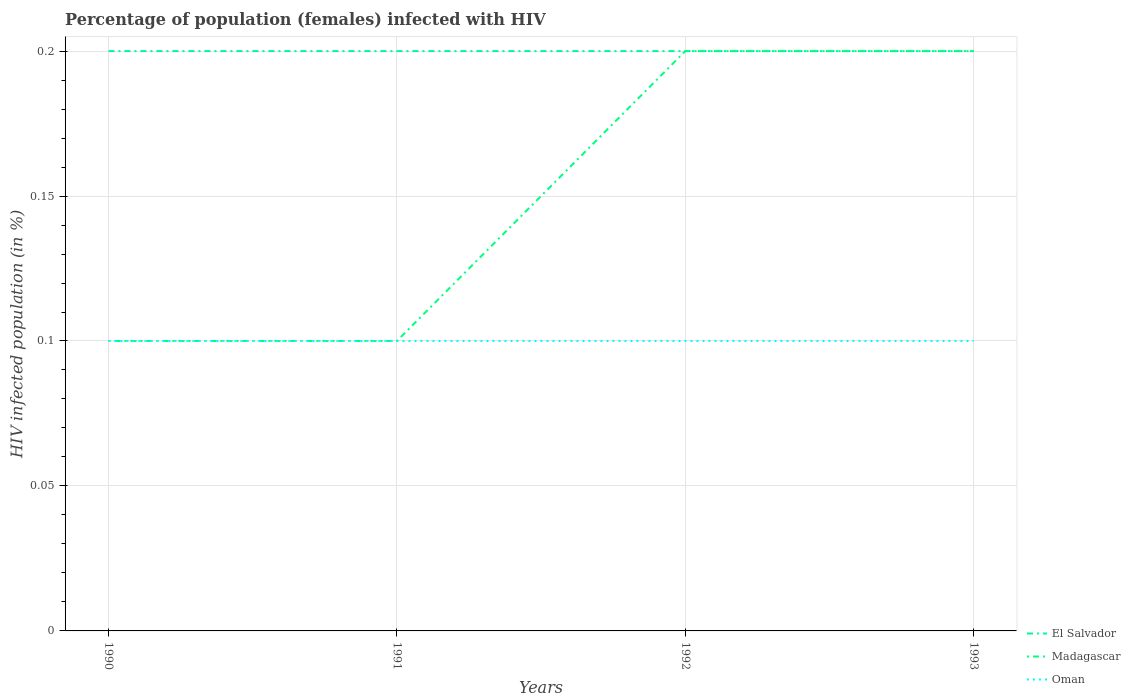How many different coloured lines are there?
Provide a short and direct response. 3. Is the number of lines equal to the number of legend labels?
Offer a terse response. Yes. In which year was the percentage of HIV infected female population in Oman maximum?
Your response must be concise. 1990. What is the difference between the highest and the second highest percentage of HIV infected female population in Madagascar?
Keep it short and to the point. 0.1. How many years are there in the graph?
Keep it short and to the point. 4. Are the values on the major ticks of Y-axis written in scientific E-notation?
Offer a very short reply. No. Does the graph contain grids?
Your answer should be very brief. Yes. Where does the legend appear in the graph?
Provide a succinct answer. Bottom right. What is the title of the graph?
Your response must be concise. Percentage of population (females) infected with HIV. Does "South Africa" appear as one of the legend labels in the graph?
Your response must be concise. No. What is the label or title of the Y-axis?
Provide a short and direct response. HIV infected population (in %). What is the HIV infected population (in %) in El Salvador in 1990?
Your answer should be very brief. 0.2. What is the HIV infected population (in %) in Oman in 1990?
Provide a short and direct response. 0.1. What is the HIV infected population (in %) of Madagascar in 1991?
Your answer should be compact. 0.1. What is the HIV infected population (in %) in Oman in 1991?
Keep it short and to the point. 0.1. What is the HIV infected population (in %) of Oman in 1992?
Provide a short and direct response. 0.1. What is the HIV infected population (in %) in El Salvador in 1993?
Your answer should be compact. 0.2. What is the HIV infected population (in %) of Madagascar in 1993?
Your answer should be very brief. 0.2. What is the HIV infected population (in %) in Oman in 1993?
Offer a very short reply. 0.1. Across all years, what is the maximum HIV infected population (in %) in El Salvador?
Give a very brief answer. 0.2. Across all years, what is the minimum HIV infected population (in %) in Madagascar?
Your answer should be compact. 0.1. Across all years, what is the minimum HIV infected population (in %) of Oman?
Ensure brevity in your answer.  0.1. What is the total HIV infected population (in %) of El Salvador in the graph?
Offer a terse response. 0.8. What is the total HIV infected population (in %) in Madagascar in the graph?
Make the answer very short. 0.6. What is the total HIV infected population (in %) in Oman in the graph?
Provide a succinct answer. 0.4. What is the difference between the HIV infected population (in %) in Madagascar in 1990 and that in 1991?
Your response must be concise. 0. What is the difference between the HIV infected population (in %) in Oman in 1990 and that in 1991?
Your answer should be compact. 0. What is the difference between the HIV infected population (in %) in El Salvador in 1990 and that in 1992?
Offer a very short reply. 0. What is the difference between the HIV infected population (in %) of Oman in 1990 and that in 1992?
Your answer should be compact. 0. What is the difference between the HIV infected population (in %) of El Salvador in 1990 and that in 1993?
Your answer should be very brief. 0. What is the difference between the HIV infected population (in %) in Madagascar in 1990 and that in 1993?
Offer a very short reply. -0.1. What is the difference between the HIV infected population (in %) of Oman in 1990 and that in 1993?
Make the answer very short. 0. What is the difference between the HIV infected population (in %) in El Salvador in 1991 and that in 1992?
Your response must be concise. 0. What is the difference between the HIV infected population (in %) in Madagascar in 1991 and that in 1992?
Your answer should be very brief. -0.1. What is the difference between the HIV infected population (in %) of Oman in 1991 and that in 1992?
Provide a succinct answer. 0. What is the difference between the HIV infected population (in %) in Madagascar in 1991 and that in 1993?
Make the answer very short. -0.1. What is the difference between the HIV infected population (in %) of Oman in 1991 and that in 1993?
Offer a terse response. 0. What is the difference between the HIV infected population (in %) in Madagascar in 1992 and that in 1993?
Your answer should be very brief. 0. What is the difference between the HIV infected population (in %) of Madagascar in 1990 and the HIV infected population (in %) of Oman in 1991?
Offer a terse response. 0. What is the difference between the HIV infected population (in %) in Madagascar in 1990 and the HIV infected population (in %) in Oman in 1992?
Your answer should be very brief. 0. What is the difference between the HIV infected population (in %) in Madagascar in 1990 and the HIV infected population (in %) in Oman in 1993?
Keep it short and to the point. 0. What is the difference between the HIV infected population (in %) in El Salvador in 1991 and the HIV infected population (in %) in Oman in 1992?
Your answer should be compact. 0.1. What is the difference between the HIV infected population (in %) in Madagascar in 1991 and the HIV infected population (in %) in Oman in 1992?
Give a very brief answer. 0. What is the difference between the HIV infected population (in %) of El Salvador in 1992 and the HIV infected population (in %) of Madagascar in 1993?
Your answer should be compact. 0. What is the difference between the HIV infected population (in %) in El Salvador in 1992 and the HIV infected population (in %) in Oman in 1993?
Offer a very short reply. 0.1. What is the difference between the HIV infected population (in %) in Madagascar in 1992 and the HIV infected population (in %) in Oman in 1993?
Your answer should be very brief. 0.1. In the year 1990, what is the difference between the HIV infected population (in %) of Madagascar and HIV infected population (in %) of Oman?
Your answer should be compact. 0. In the year 1991, what is the difference between the HIV infected population (in %) in El Salvador and HIV infected population (in %) in Oman?
Give a very brief answer. 0.1. In the year 1991, what is the difference between the HIV infected population (in %) of Madagascar and HIV infected population (in %) of Oman?
Make the answer very short. 0. In the year 1992, what is the difference between the HIV infected population (in %) of El Salvador and HIV infected population (in %) of Madagascar?
Keep it short and to the point. 0. In the year 1992, what is the difference between the HIV infected population (in %) in El Salvador and HIV infected population (in %) in Oman?
Provide a succinct answer. 0.1. In the year 1993, what is the difference between the HIV infected population (in %) in El Salvador and HIV infected population (in %) in Oman?
Ensure brevity in your answer.  0.1. What is the ratio of the HIV infected population (in %) in Oman in 1990 to that in 1991?
Your answer should be very brief. 1. What is the ratio of the HIV infected population (in %) of Madagascar in 1990 to that in 1992?
Ensure brevity in your answer.  0.5. What is the ratio of the HIV infected population (in %) in El Salvador in 1990 to that in 1993?
Your response must be concise. 1. What is the ratio of the HIV infected population (in %) in Madagascar in 1990 to that in 1993?
Make the answer very short. 0.5. What is the ratio of the HIV infected population (in %) of El Salvador in 1991 to that in 1993?
Your response must be concise. 1. What is the ratio of the HIV infected population (in %) of Oman in 1992 to that in 1993?
Your answer should be very brief. 1. What is the difference between the highest and the second highest HIV infected population (in %) in Madagascar?
Offer a terse response. 0. What is the difference between the highest and the second highest HIV infected population (in %) in Oman?
Provide a succinct answer. 0. What is the difference between the highest and the lowest HIV infected population (in %) of El Salvador?
Keep it short and to the point. 0. 